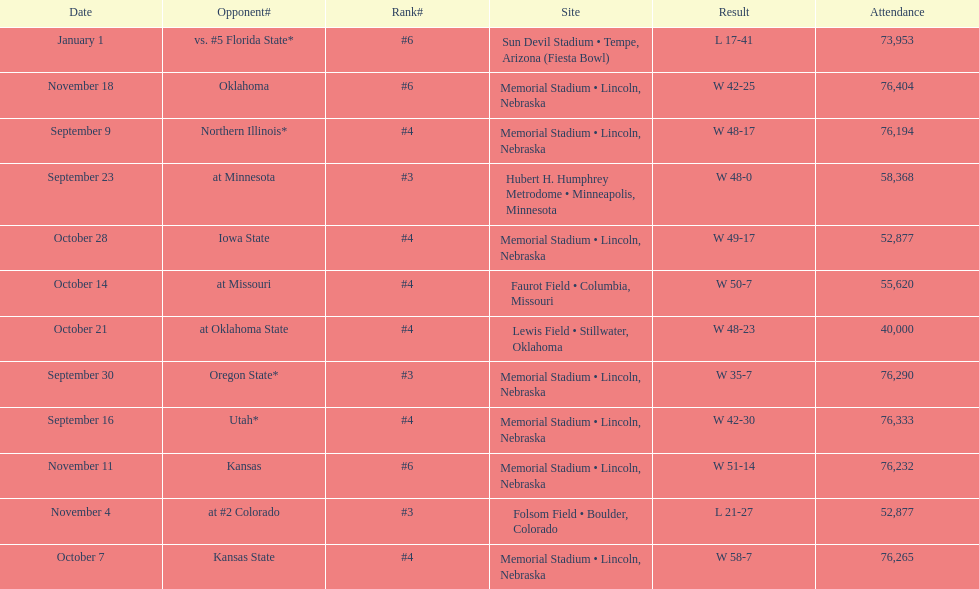Who were all of their opponents? Northern Illinois*, Utah*, at Minnesota, Oregon State*, Kansas State, at Missouri, at Oklahoma State, Iowa State, at #2 Colorado, Kansas, Oklahoma, vs. #5 Florida State*. And what was the attendance of these games? 76,194, 76,333, 58,368, 76,290, 76,265, 55,620, 40,000, 52,877, 52,877, 76,232, 76,404, 73,953. Of those numbers, which is associated with the oregon state game? 76,290. 